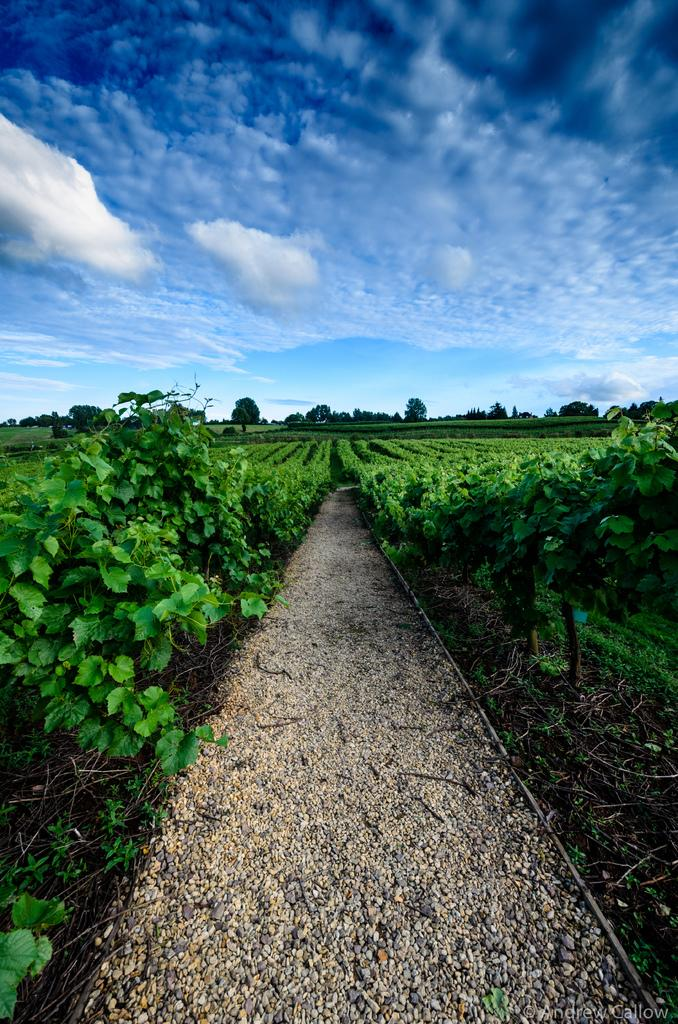What type of vegetation can be seen in the image? There are plants and trees in the image. What is visible in the background of the image? The sky is visible in the background of the image. How do the clouds in the sky appear? The clouds in the sky appear heavy. What letters can be seen on the plants in the image? There are no letters present on the plants in the image. What time of day is it in the image, given that it is morning? The time of day is not mentioned in the image, and there is no indication that it is morning. 